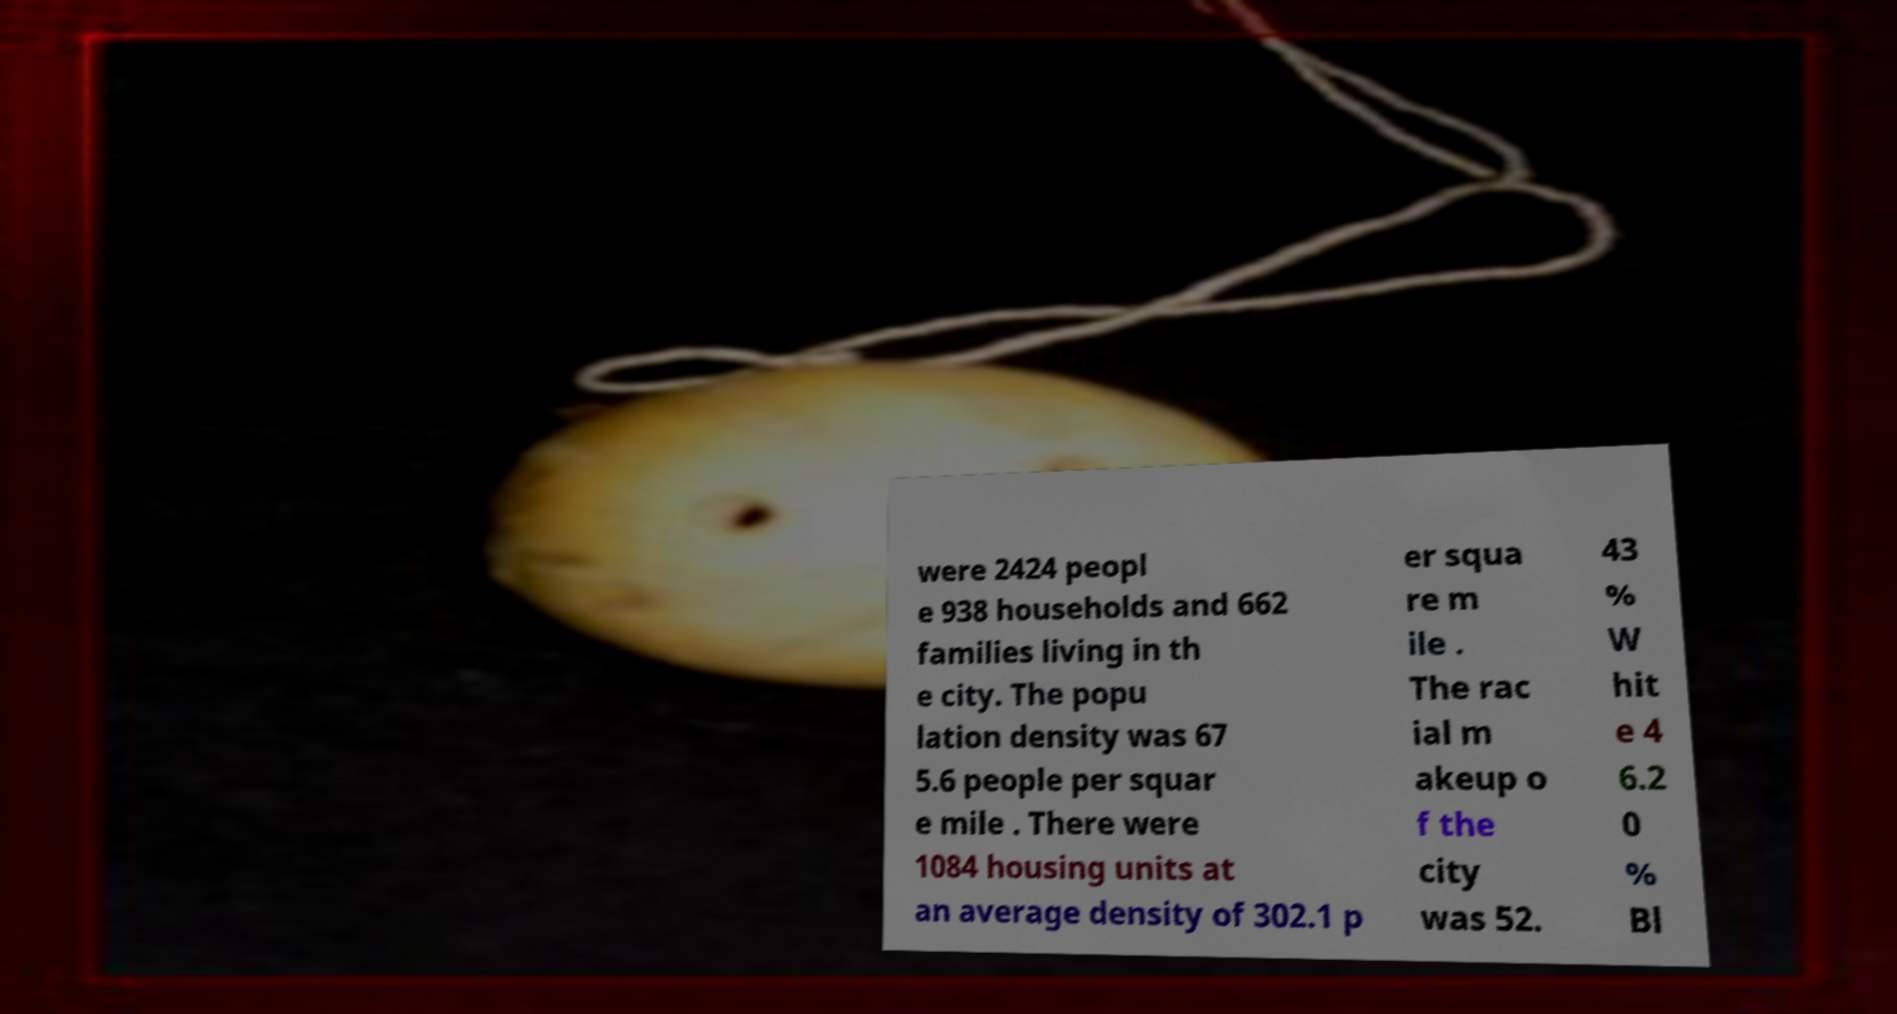Please read and relay the text visible in this image. What does it say? were 2424 peopl e 938 households and 662 families living in th e city. The popu lation density was 67 5.6 people per squar e mile . There were 1084 housing units at an average density of 302.1 p er squa re m ile . The rac ial m akeup o f the city was 52. 43 % W hit e 4 6.2 0 % Bl 